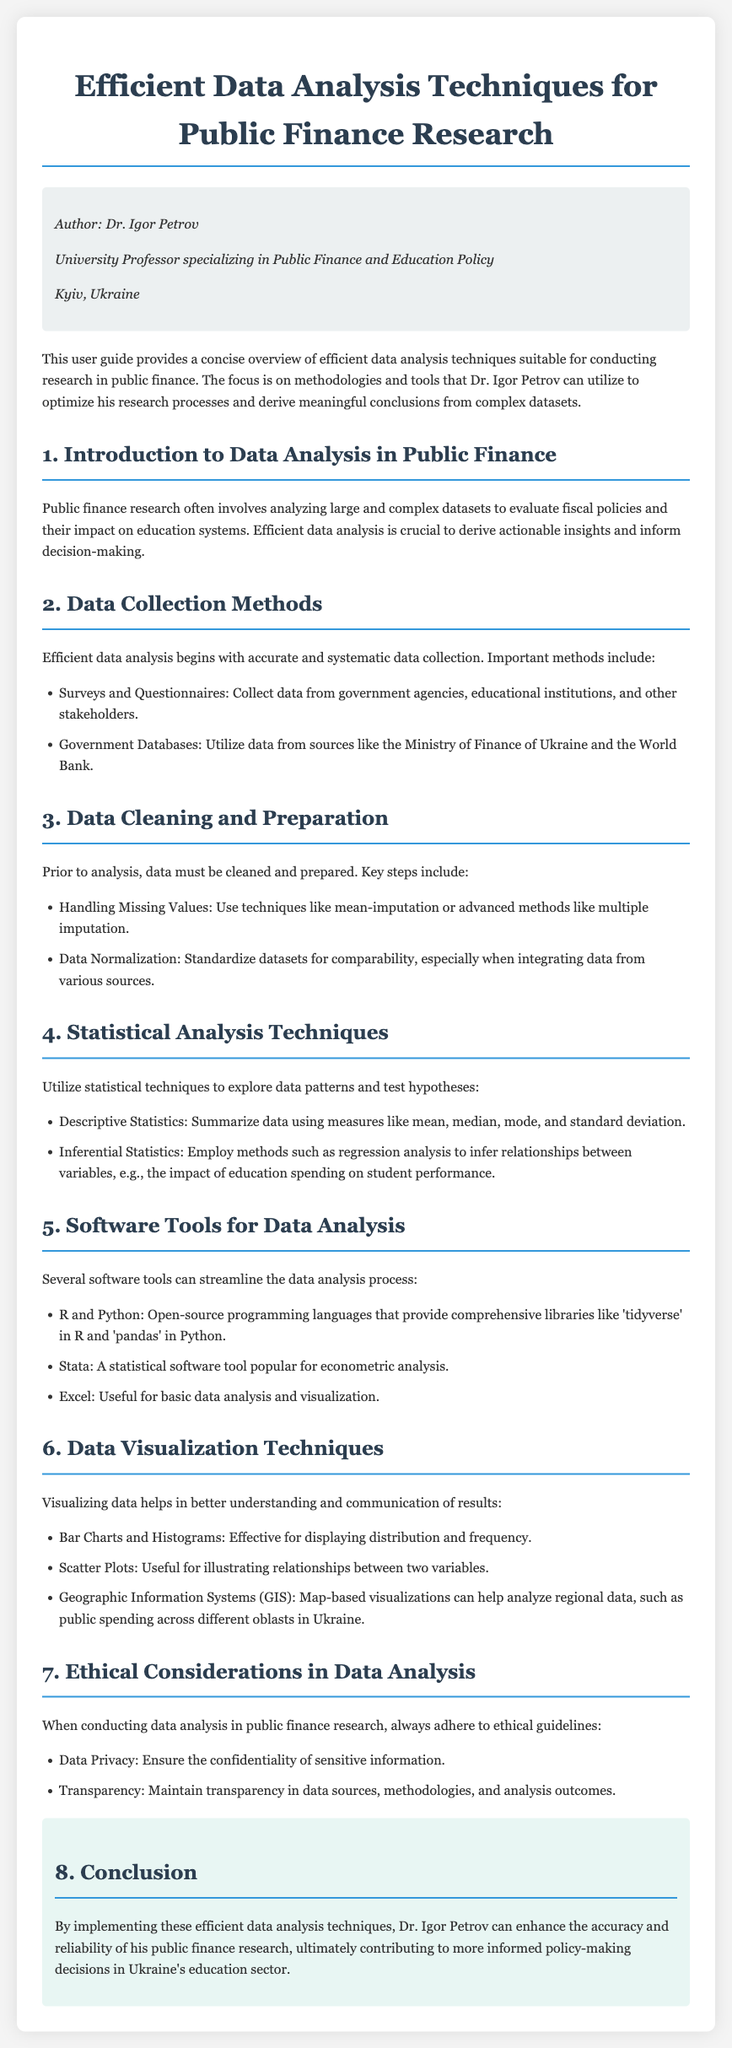what is the title of the document? The title is prominently displayed at the top of the document, which provides the main subject.
Answer: Efficient Data Analysis Techniques for Public Finance Research who is the author of the document? The author is introduced in the author info section that includes their title and specialization.
Answer: Dr. Igor Petrov which software tool is mentioned first for data analysis? The document lists various software tools under a specific section, with the first mentioned being relevant to programming languages.
Answer: R and Python what is the purpose of data visualization in public finance research? The document explains that visualization aids in understanding and communicating results.
Answer: Better understanding and communication list one method of data collection mentioned in the document. The document describes methods for data collection, such as surveys.
Answer: Surveys and Questionnaires which statistical method is suggested for inferring relationships between variables? The document details statistical analysis techniques, including regression analysis for hypothesis testing.
Answer: Regression analysis what is a key ethical consideration in data analysis? Ethical guidelines are discussed in the document, focusing on specific values to uphold during analysis.
Answer: Data Privacy what type of chart is effective for displaying distribution? The document provides examples of data visualization techniques that are particularly useful.
Answer: Bar Charts and Histograms 